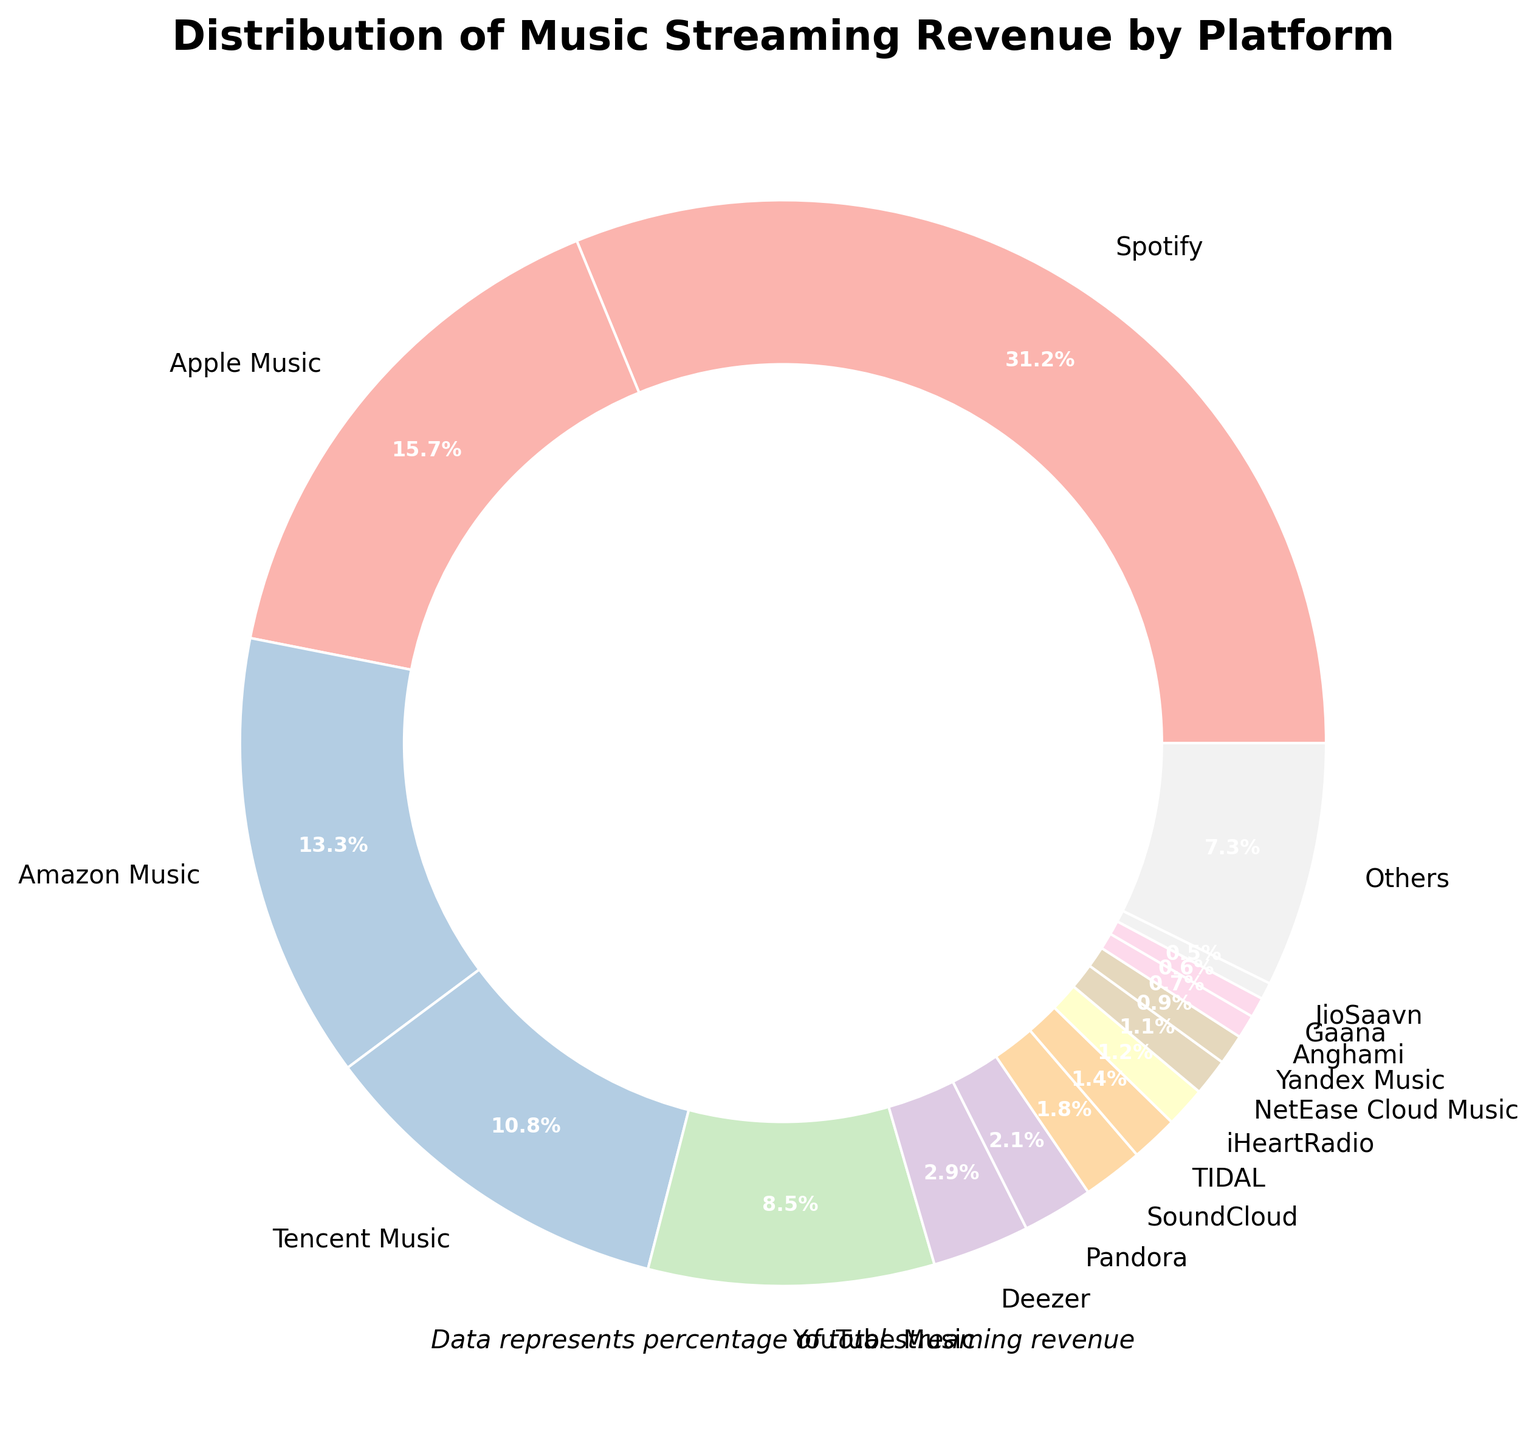Which platform generates the most revenue? The platform with the largest slice in the pie chart and the highest percentage label generates the most revenue. Referring to the figure, Spotify has the largest slice and is labeled 31.2%.
Answer: Spotify By how much does Spotify's revenue percentage exceed Apple Music's? Spotify has 31.2% and Apple Music has 15.7%. The difference is calculated by subtracting Apple Music's percentage from Spotify's percentage: 31.2% - 15.7% = 15.5%.
Answer: 15.5% Which platforms combined have a revenue percentage closest to Netflix's market share of 20%? The platforms with smaller percentages should be summed until the total is close to 20%. Combining Tencent Music (10.8%) and YouTube Music (8.5%) gives 19.3%, which is very close to 20%.
Answer: Tencent Music and YouTube Music Rank the top three platforms by revenue percentage. The largest three slices in the pie chart represent the top three platforms. Ordered by percentage: Spotify (31.2%), Apple Music (15.7%), and Amazon Music (13.3%).
Answer: Spotify, Apple Music, Amazon Music Identify the platforms that individually have less than 1% revenue share. The platforms with percentages less than 1% are typically smaller slices towards the end of the list: NetEase Cloud Music (1.1%) does not qualify, while Yandex Music (0.9%), Anghami (0.7%), Gaana (0.6%), and JioSaavn (0.5%) do.
Answer: Yandex Music, Anghami, Gaana, JioSaavn Is YouTube Music's revenue percentage greater than twice that of Pandora? YouTube Music's percentage is 8.5%. Twice Pandora's percentage would be 2.1% * 2 = 4.2%. Since 8.5% is greater than 4.2%, the answer is yes.
Answer: Yes How does the combined revenue percentage of Deezer and Pandora compare to Amazon Music's? Deezer has 2.9% and Pandora has 2.1%. Combined, they have 2.9% + 2.1% = 5.0%, which is less than Amazon Music's 13.3%.
Answer: Less What is the combined revenue percentage of the top five platforms? Add the percentages of the top five platforms: Spotify (31.2%), Apple Music (15.7%), Amazon Music (13.3%), Tencent Music (10.8%), and YouTube Music (8.5%). The sum is 31.2% + 15.7% + 13.3% + 10.8% + 8.5% = 79.5%.
Answer: 79.5% Which platforms are represented by the pastel green and pastel blue slices? By examining the colors in the pastel color scheme used, the notable pastel green and pastel blue slices can be identified. Assuming 'pastel green' as earlier slice due to listing order, Spotify is pastel green (largest), and Apple Music is pastel blue (second largest).
Answer: Spotify and Apple Music 